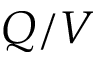<formula> <loc_0><loc_0><loc_500><loc_500>Q / V</formula> 